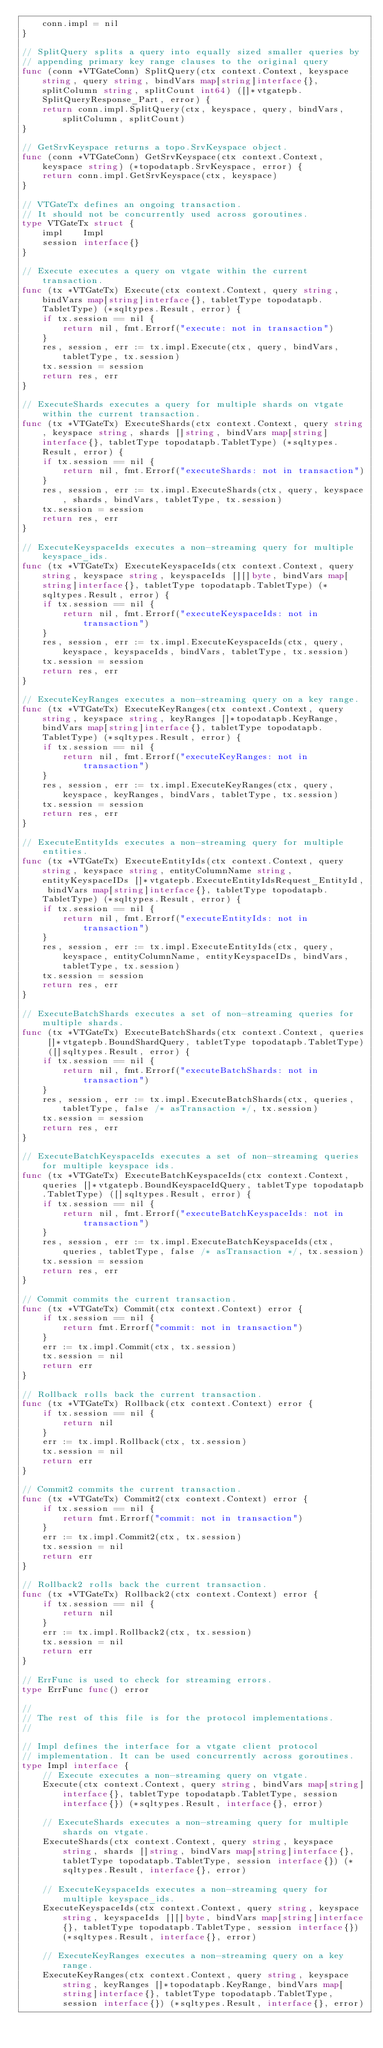Convert code to text. <code><loc_0><loc_0><loc_500><loc_500><_Go_>	conn.impl = nil
}

// SplitQuery splits a query into equally sized smaller queries by
// appending primary key range clauses to the original query
func (conn *VTGateConn) SplitQuery(ctx context.Context, keyspace string, query string, bindVars map[string]interface{}, splitColumn string, splitCount int64) ([]*vtgatepb.SplitQueryResponse_Part, error) {
	return conn.impl.SplitQuery(ctx, keyspace, query, bindVars, splitColumn, splitCount)
}

// GetSrvKeyspace returns a topo.SrvKeyspace object.
func (conn *VTGateConn) GetSrvKeyspace(ctx context.Context, keyspace string) (*topodatapb.SrvKeyspace, error) {
	return conn.impl.GetSrvKeyspace(ctx, keyspace)
}

// VTGateTx defines an ongoing transaction.
// It should not be concurrently used across goroutines.
type VTGateTx struct {
	impl    Impl
	session interface{}
}

// Execute executes a query on vtgate within the current transaction.
func (tx *VTGateTx) Execute(ctx context.Context, query string, bindVars map[string]interface{}, tabletType topodatapb.TabletType) (*sqltypes.Result, error) {
	if tx.session == nil {
		return nil, fmt.Errorf("execute: not in transaction")
	}
	res, session, err := tx.impl.Execute(ctx, query, bindVars, tabletType, tx.session)
	tx.session = session
	return res, err
}

// ExecuteShards executes a query for multiple shards on vtgate within the current transaction.
func (tx *VTGateTx) ExecuteShards(ctx context.Context, query string, keyspace string, shards []string, bindVars map[string]interface{}, tabletType topodatapb.TabletType) (*sqltypes.Result, error) {
	if tx.session == nil {
		return nil, fmt.Errorf("executeShards: not in transaction")
	}
	res, session, err := tx.impl.ExecuteShards(ctx, query, keyspace, shards, bindVars, tabletType, tx.session)
	tx.session = session
	return res, err
}

// ExecuteKeyspaceIds executes a non-streaming query for multiple keyspace_ids.
func (tx *VTGateTx) ExecuteKeyspaceIds(ctx context.Context, query string, keyspace string, keyspaceIds [][]byte, bindVars map[string]interface{}, tabletType topodatapb.TabletType) (*sqltypes.Result, error) {
	if tx.session == nil {
		return nil, fmt.Errorf("executeKeyspaceIds: not in transaction")
	}
	res, session, err := tx.impl.ExecuteKeyspaceIds(ctx, query, keyspace, keyspaceIds, bindVars, tabletType, tx.session)
	tx.session = session
	return res, err
}

// ExecuteKeyRanges executes a non-streaming query on a key range.
func (tx *VTGateTx) ExecuteKeyRanges(ctx context.Context, query string, keyspace string, keyRanges []*topodatapb.KeyRange, bindVars map[string]interface{}, tabletType topodatapb.TabletType) (*sqltypes.Result, error) {
	if tx.session == nil {
		return nil, fmt.Errorf("executeKeyRanges: not in transaction")
	}
	res, session, err := tx.impl.ExecuteKeyRanges(ctx, query, keyspace, keyRanges, bindVars, tabletType, tx.session)
	tx.session = session
	return res, err
}

// ExecuteEntityIds executes a non-streaming query for multiple entities.
func (tx *VTGateTx) ExecuteEntityIds(ctx context.Context, query string, keyspace string, entityColumnName string, entityKeyspaceIDs []*vtgatepb.ExecuteEntityIdsRequest_EntityId, bindVars map[string]interface{}, tabletType topodatapb.TabletType) (*sqltypes.Result, error) {
	if tx.session == nil {
		return nil, fmt.Errorf("executeEntityIds: not in transaction")
	}
	res, session, err := tx.impl.ExecuteEntityIds(ctx, query, keyspace, entityColumnName, entityKeyspaceIDs, bindVars, tabletType, tx.session)
	tx.session = session
	return res, err
}

// ExecuteBatchShards executes a set of non-streaming queries for multiple shards.
func (tx *VTGateTx) ExecuteBatchShards(ctx context.Context, queries []*vtgatepb.BoundShardQuery, tabletType topodatapb.TabletType) ([]sqltypes.Result, error) {
	if tx.session == nil {
		return nil, fmt.Errorf("executeBatchShards: not in transaction")
	}
	res, session, err := tx.impl.ExecuteBatchShards(ctx, queries, tabletType, false /* asTransaction */, tx.session)
	tx.session = session
	return res, err
}

// ExecuteBatchKeyspaceIds executes a set of non-streaming queries for multiple keyspace ids.
func (tx *VTGateTx) ExecuteBatchKeyspaceIds(ctx context.Context, queries []*vtgatepb.BoundKeyspaceIdQuery, tabletType topodatapb.TabletType) ([]sqltypes.Result, error) {
	if tx.session == nil {
		return nil, fmt.Errorf("executeBatchKeyspaceIds: not in transaction")
	}
	res, session, err := tx.impl.ExecuteBatchKeyspaceIds(ctx, queries, tabletType, false /* asTransaction */, tx.session)
	tx.session = session
	return res, err
}

// Commit commits the current transaction.
func (tx *VTGateTx) Commit(ctx context.Context) error {
	if tx.session == nil {
		return fmt.Errorf("commit: not in transaction")
	}
	err := tx.impl.Commit(ctx, tx.session)
	tx.session = nil
	return err
}

// Rollback rolls back the current transaction.
func (tx *VTGateTx) Rollback(ctx context.Context) error {
	if tx.session == nil {
		return nil
	}
	err := tx.impl.Rollback(ctx, tx.session)
	tx.session = nil
	return err
}

// Commit2 commits the current transaction.
func (tx *VTGateTx) Commit2(ctx context.Context) error {
	if tx.session == nil {
		return fmt.Errorf("commit: not in transaction")
	}
	err := tx.impl.Commit2(ctx, tx.session)
	tx.session = nil
	return err
}

// Rollback2 rolls back the current transaction.
func (tx *VTGateTx) Rollback2(ctx context.Context) error {
	if tx.session == nil {
		return nil
	}
	err := tx.impl.Rollback2(ctx, tx.session)
	tx.session = nil
	return err
}

// ErrFunc is used to check for streaming errors.
type ErrFunc func() error

//
// The rest of this file is for the protocol implementations.
//

// Impl defines the interface for a vtgate client protocol
// implementation. It can be used concurrently across goroutines.
type Impl interface {
	// Execute executes a non-streaming query on vtgate.
	Execute(ctx context.Context, query string, bindVars map[string]interface{}, tabletType topodatapb.TabletType, session interface{}) (*sqltypes.Result, interface{}, error)

	// ExecuteShards executes a non-streaming query for multiple shards on vtgate.
	ExecuteShards(ctx context.Context, query string, keyspace string, shards []string, bindVars map[string]interface{}, tabletType topodatapb.TabletType, session interface{}) (*sqltypes.Result, interface{}, error)

	// ExecuteKeyspaceIds executes a non-streaming query for multiple keyspace_ids.
	ExecuteKeyspaceIds(ctx context.Context, query string, keyspace string, keyspaceIds [][]byte, bindVars map[string]interface{}, tabletType topodatapb.TabletType, session interface{}) (*sqltypes.Result, interface{}, error)

	// ExecuteKeyRanges executes a non-streaming query on a key range.
	ExecuteKeyRanges(ctx context.Context, query string, keyspace string, keyRanges []*topodatapb.KeyRange, bindVars map[string]interface{}, tabletType topodatapb.TabletType, session interface{}) (*sqltypes.Result, interface{}, error)
</code> 